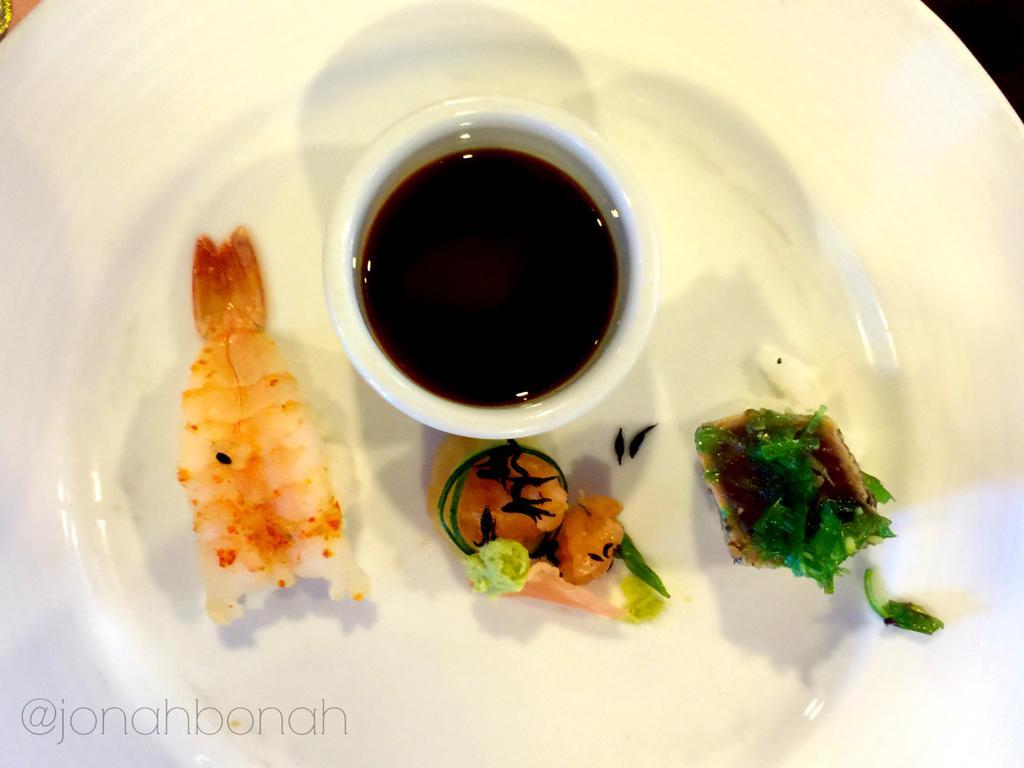In one or two sentences, can you explain what this image depicts? This picture shows food in the plate and we see sauce in a bowl and a watermark at the bottom left corner of the picture. 